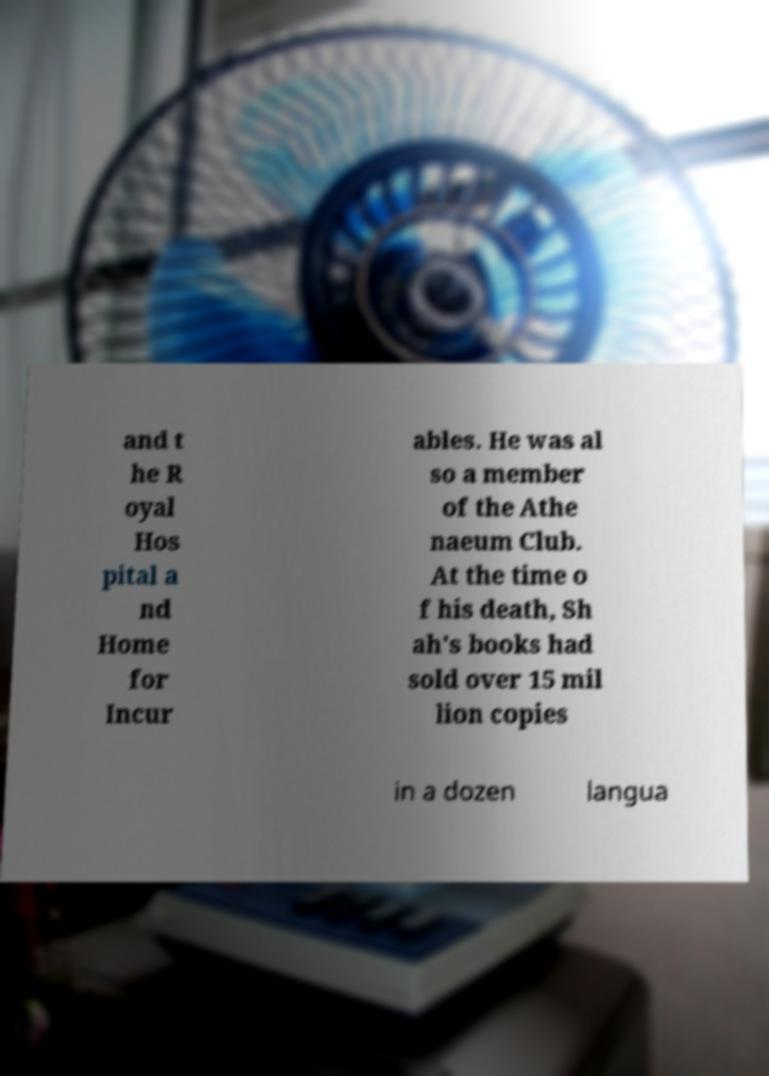Please identify and transcribe the text found in this image. and t he R oyal Hos pital a nd Home for Incur ables. He was al so a member of the Athe naeum Club. At the time o f his death, Sh ah's books had sold over 15 mil lion copies in a dozen langua 